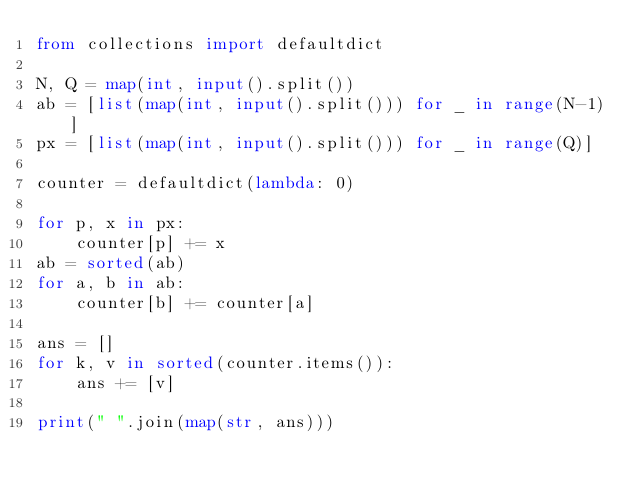<code> <loc_0><loc_0><loc_500><loc_500><_Python_>from collections import defaultdict

N, Q = map(int, input().split())
ab = [list(map(int, input().split())) for _ in range(N-1)]
px = [list(map(int, input().split())) for _ in range(Q)]

counter = defaultdict(lambda: 0)

for p, x in px:
    counter[p] += x
ab = sorted(ab)
for a, b in ab:
    counter[b] += counter[a]

ans = []
for k, v in sorted(counter.items()):
    ans += [v]

print(" ".join(map(str, ans)))</code> 